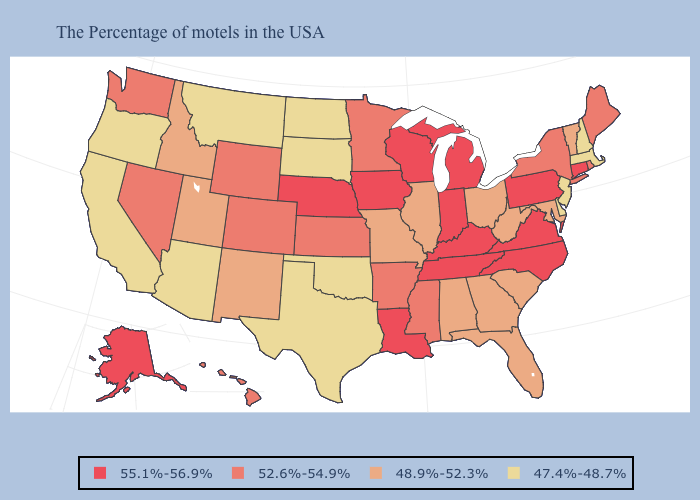What is the highest value in states that border Texas?
Keep it brief. 55.1%-56.9%. What is the value of Colorado?
Be succinct. 52.6%-54.9%. What is the value of Wyoming?
Concise answer only. 52.6%-54.9%. Which states hav the highest value in the South?
Answer briefly. Virginia, North Carolina, Kentucky, Tennessee, Louisiana. Among the states that border Maryland , does Delaware have the lowest value?
Write a very short answer. Yes. Does Virginia have the highest value in the USA?
Concise answer only. Yes. Name the states that have a value in the range 52.6%-54.9%?
Concise answer only. Maine, Rhode Island, New York, Mississippi, Arkansas, Minnesota, Kansas, Wyoming, Colorado, Nevada, Washington, Hawaii. What is the value of North Dakota?
Quick response, please. 47.4%-48.7%. What is the value of Delaware?
Quick response, please. 47.4%-48.7%. What is the highest value in the USA?
Write a very short answer. 55.1%-56.9%. What is the lowest value in the USA?
Be succinct. 47.4%-48.7%. Name the states that have a value in the range 47.4%-48.7%?
Concise answer only. Massachusetts, New Hampshire, New Jersey, Delaware, Oklahoma, Texas, South Dakota, North Dakota, Montana, Arizona, California, Oregon. What is the lowest value in the USA?
Concise answer only. 47.4%-48.7%. Name the states that have a value in the range 52.6%-54.9%?
Concise answer only. Maine, Rhode Island, New York, Mississippi, Arkansas, Minnesota, Kansas, Wyoming, Colorado, Nevada, Washington, Hawaii. Does the first symbol in the legend represent the smallest category?
Answer briefly. No. 